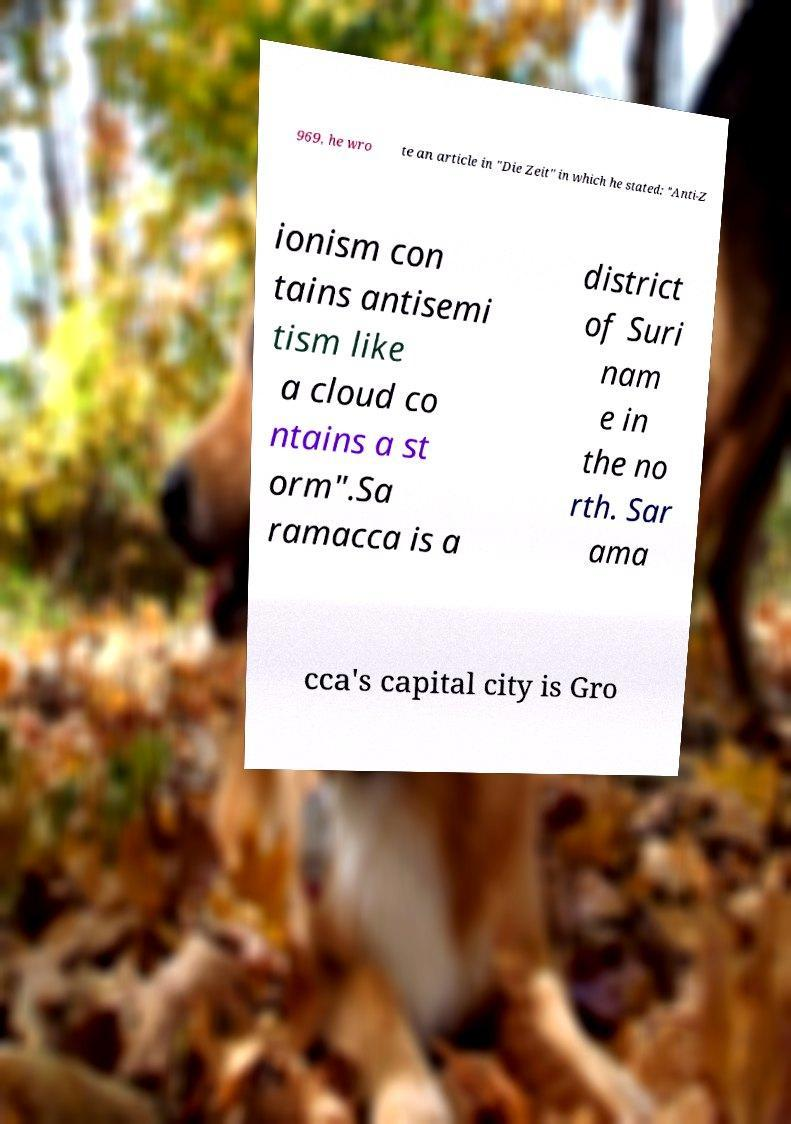Please identify and transcribe the text found in this image. 969, he wro te an article in "Die Zeit" in which he stated: "Anti-Z ionism con tains antisemi tism like a cloud co ntains a st orm".Sa ramacca is a district of Suri nam e in the no rth. Sar ama cca's capital city is Gro 